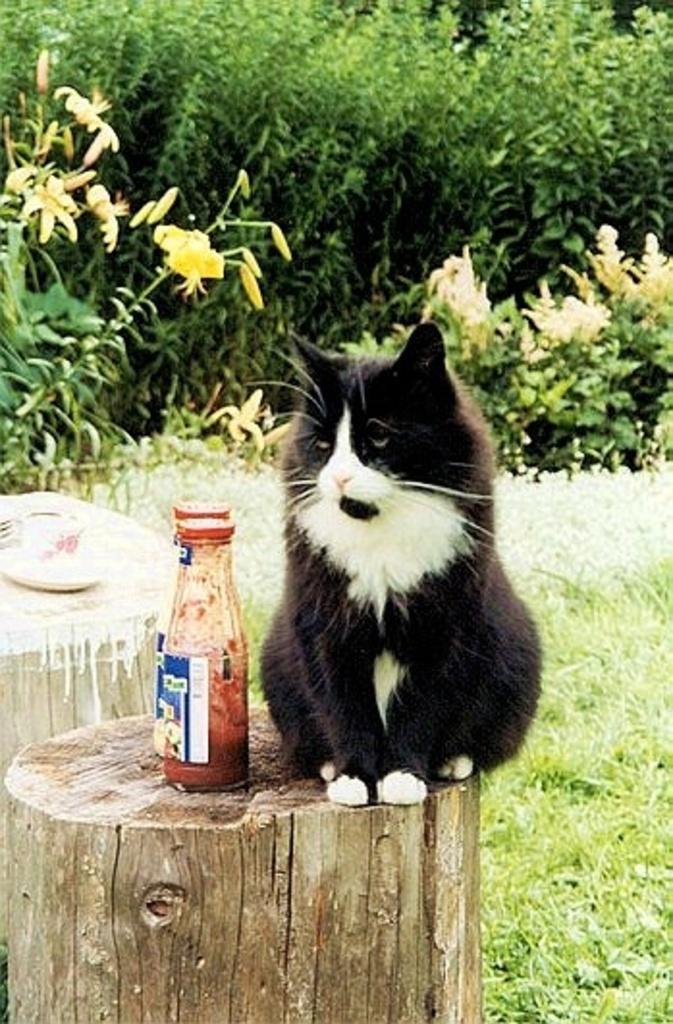Could you give a brief overview of what you see in this image? In this image I see a cat which is sitting and there are 2 bottles side to the cat. In the background I see the plants and the grass. 